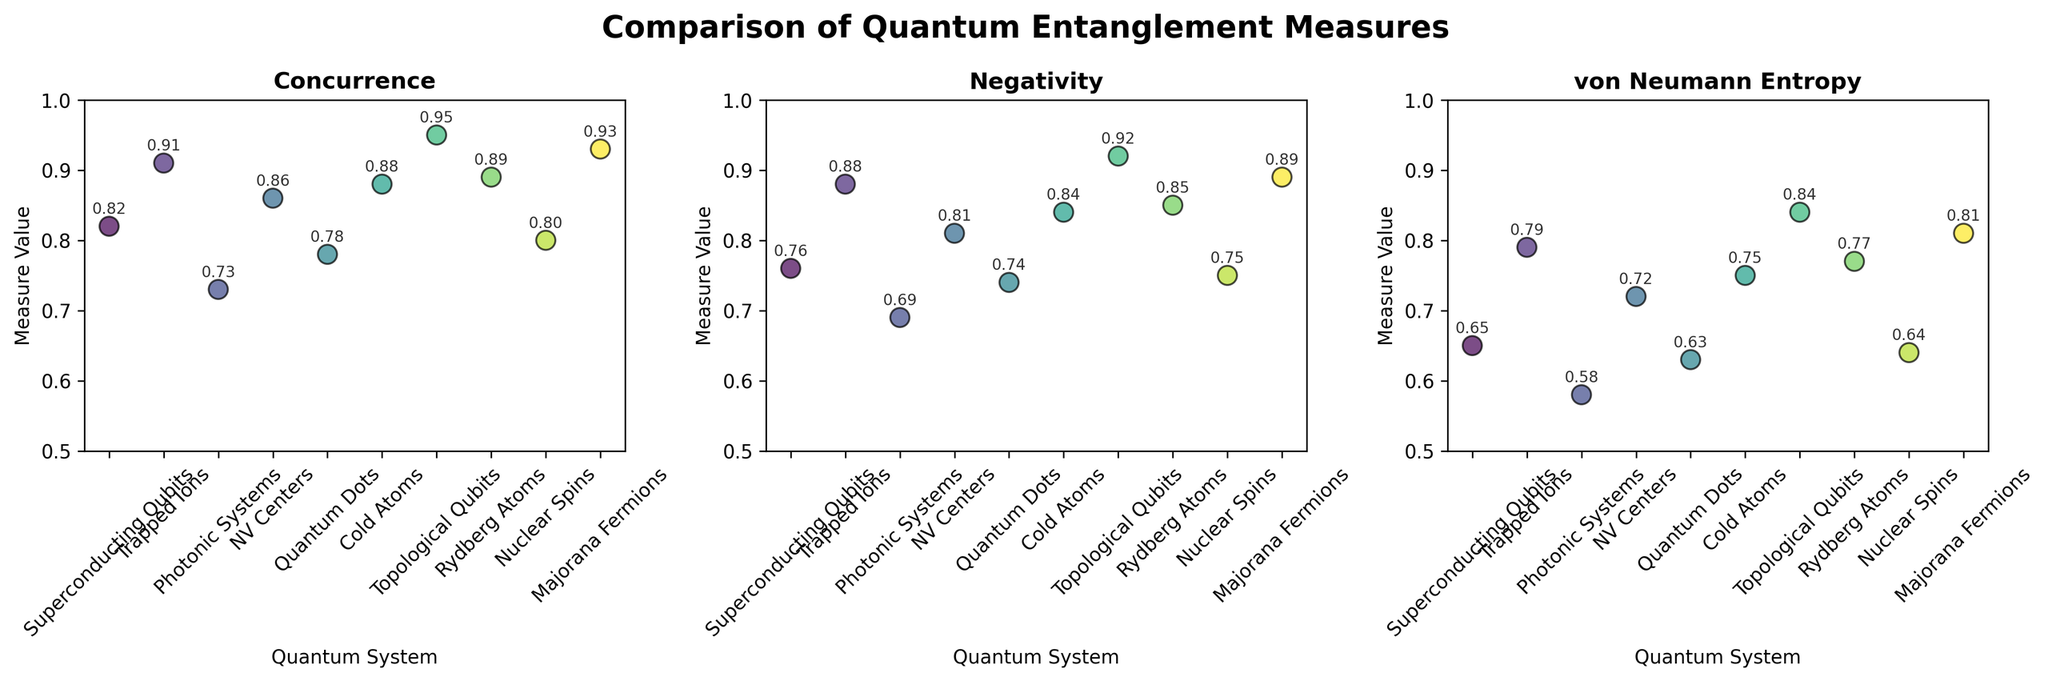What is the title of the figure? The title is displayed at the top of the figure and reads "Comparison of Quantum Entanglement Measures"
Answer: Comparison of Quantum Entanglement Measures Which quantum system has the highest Concurrence? By inspecting the Concurrence values in the scatter plot, "Topological Qubits" has the highest value of 0.95
Answer: Topological Qubits How many different quantum systems are compared in the figure? Each scatter plot has 10 unique data points representing different quantum systems. Hence, 10 quantum systems are compared
Answer: 10 Which entanglement measure has the highest value for "Trapped Ions"? In the scatter plot for "Trapped Ions," the values are 0.91 for Concurrence, 0.88 for Negativity, and 0.79 for von Neumann Entropy; hence, Concurrence has the highest value
Answer: Concurrence What is the sum of Negativity and von Neumann Entropy values for "Majorana Fermions"? The Negativity value for "Majorana Fermions" is 0.89, and von Neumann Entropy is 0.81. Summing these two values gives 1.70
Answer: 1.70 Which quantum system has the lowest von Neumann Entropy value, and what is the value? By checking all von Neumann Entropy values in the scatter plot, "Photonic Systems" has the lowest value of 0.58
Answer: Photonic Systems, 0.58 Compare the von Neumann Entropy values of "Quantum Dots" and "Cold Atoms." Which is higher? The von Neumann Entropy for "Quantum Dots" is 0.63, and for "Cold Atoms" it is 0.75; hence, "Cold Atoms" has a higher value
Answer: Cold Atoms What is the average Negativity value across all quantum systems? Summing up all Negativity values (0.76 + 0.88 + 0.69 + 0.81 + 0.74 + 0.84 + 0.92 + 0.85 + 0.75 + 0.89) gives 8.13. Dividing the sum by 10 gives the average, which is 0.813
Answer: 0.813 Which entanglement measure appears to have the most consistent (least variable) values across all quantum systems? By visually inspecting the scatter plots, Negativity values seem to show the least variation compared to Concurrence and von Neumann Entropy
Answer: Negativity 